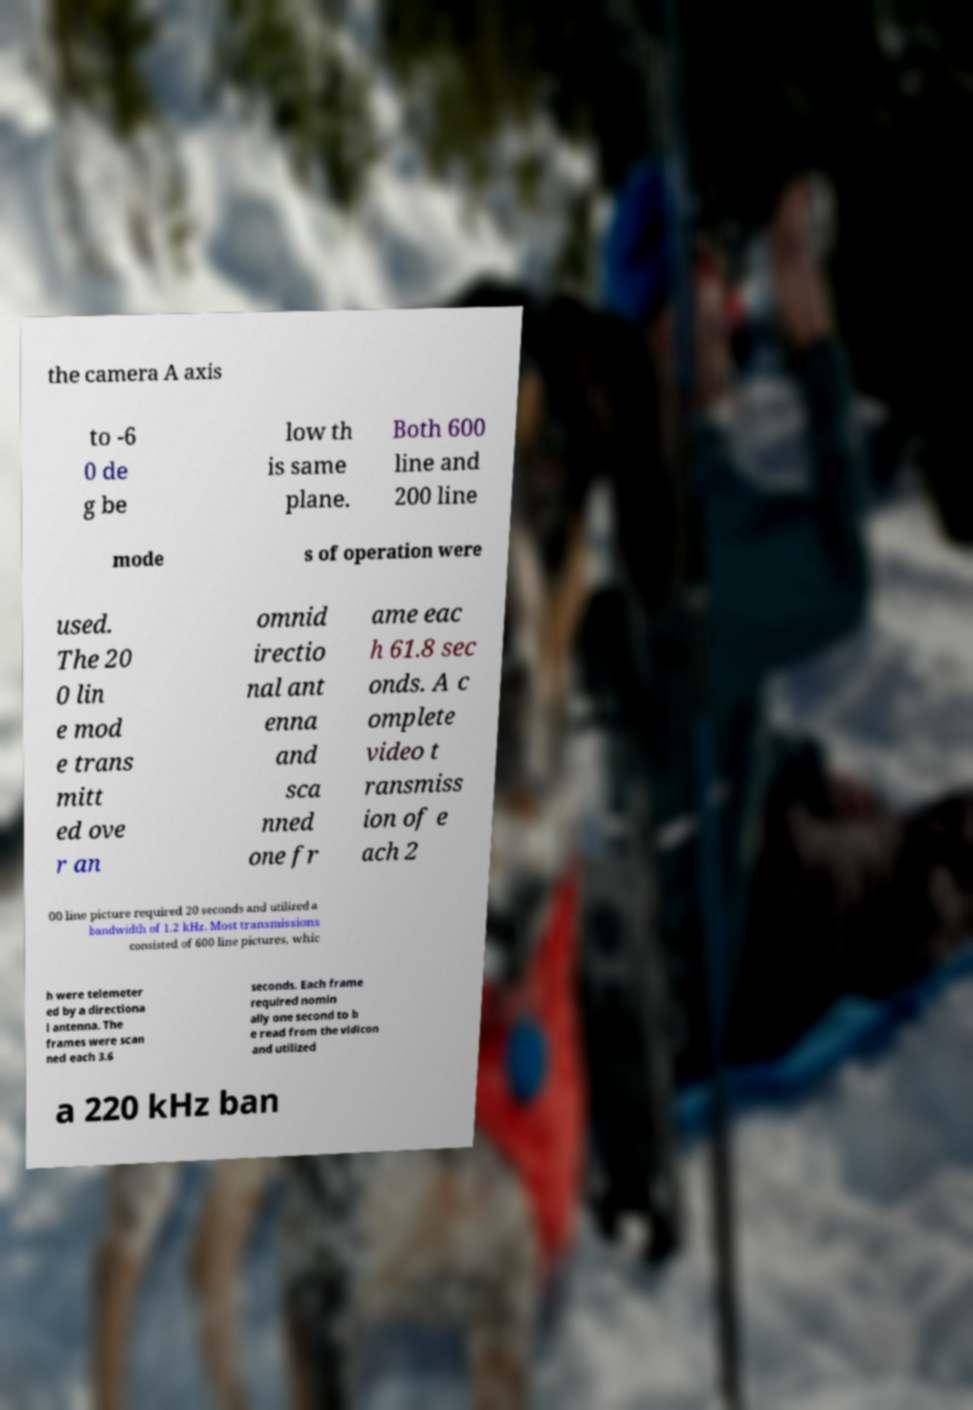For documentation purposes, I need the text within this image transcribed. Could you provide that? the camera A axis to -6 0 de g be low th is same plane. Both 600 line and 200 line mode s of operation were used. The 20 0 lin e mod e trans mitt ed ove r an omnid irectio nal ant enna and sca nned one fr ame eac h 61.8 sec onds. A c omplete video t ransmiss ion of e ach 2 00 line picture required 20 seconds and utilized a bandwidth of 1.2 kHz. Most transmissions consisted of 600 line pictures, whic h were telemeter ed by a directiona l antenna. The frames were scan ned each 3.6 seconds. Each frame required nomin ally one second to b e read from the vidicon and utilized a 220 kHz ban 